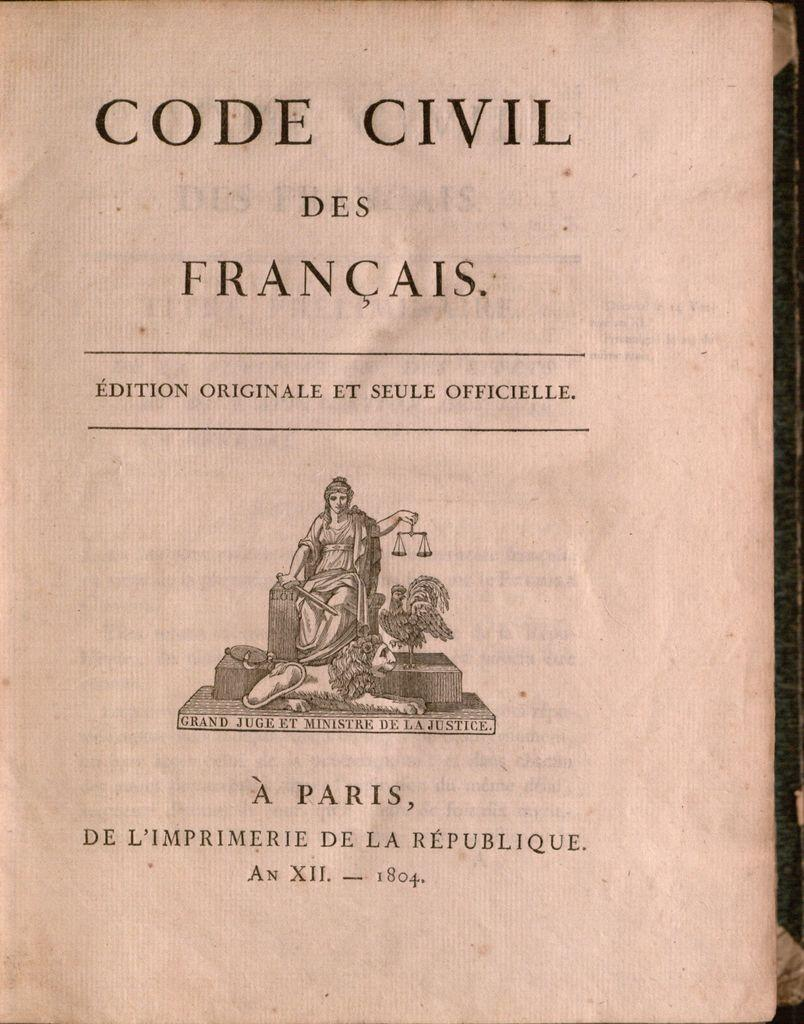<image>
Share a concise interpretation of the image provided. A book that's an original edition of the Code Civil des Francais. 